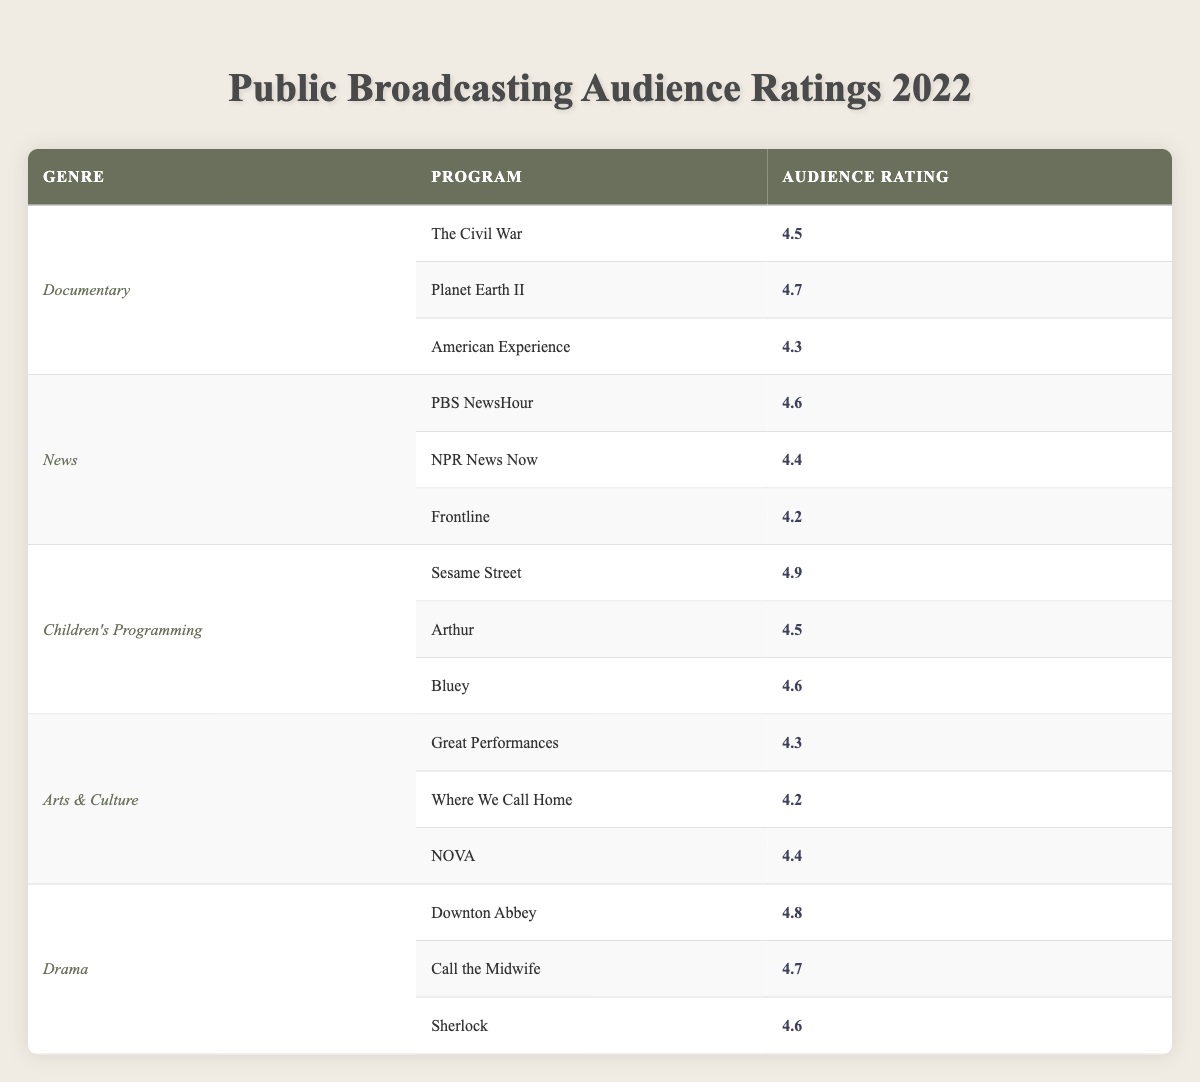What is the highest audience rating among the documentary programs? The documentary programs listed are "The Civil War" (4.5), "Planet Earth II" (4.7), and "American Experience" (4.3). The highest rating is 4.7 from "Planet Earth II."
Answer: 4.7 Which children's program received the lowest audience rating? The children's programs are "Sesame Street" (4.9), "Arthur" (4.5), and "Bluey" (4.6). Among them, "Arthur" has the lowest rating of 4.5.
Answer: Arthur Is "Downton Abbey" rated higher than the average rating of all drama programs? The drama programs are "Downton Abbey" (4.8), "Call the Midwife" (4.7), and "Sherlock" (4.6). The average is (4.8 + 4.7 + 4.6) / 3 = 4.7. "Downton Abbey" (4.8) is higher than the average (4.7).
Answer: Yes What is the total audience rating sum for all news programs? The news programs are "PBS NewsHour" (4.6), "NPR News Now" (4.4), and "Frontline" (4.2). The total sum is 4.6 + 4.4 + 4.2 = 13.2.
Answer: 13.2 Does "Planet Earth II" have a higher audience rating than "NOVA"? "Planet Earth II" has a rating of 4.7, while "NOVA" has a rating of 4.4, indicating that "Planet Earth II" is rated higher.
Answer: Yes Which genre has the highest average audience rating? The averages for the genres can be calculated as follows: Documentary: (4.5 + 4.7 + 4.3) / 3 = 4.5; News: (4.6 + 4.4 + 4.2) / 3 = 4.4; Children's Programming: (4.9 + 4.5 + 4.6) / 3 = 4.67; Arts & Culture: (4.3 + 4.2 + 4.4) / 3 = 4.33; Drama: (4.8 + 4.7 + 4.6) / 3 = 4.7. The genre with the highest average is Children's Programming (4.67).
Answer: Children's Programming What is the audience rating difference between "Sesame Street" and "Arthur"? The audience rating for "Sesame Street" is 4.9 and for "Arthur" is 4.5. The difference is 4.9 - 4.5 = 0.4.
Answer: 0.4 Which program has the second highest audience rating in the drama genre? The drama programs are "Downton Abbey" (4.8), "Call the Midwife" (4.7), and "Sherlock" (4.6). The second highest rating belongs to "Call the Midwife" with a rating of 4.7, following "Downton Abbey."
Answer: Call the Midwife 